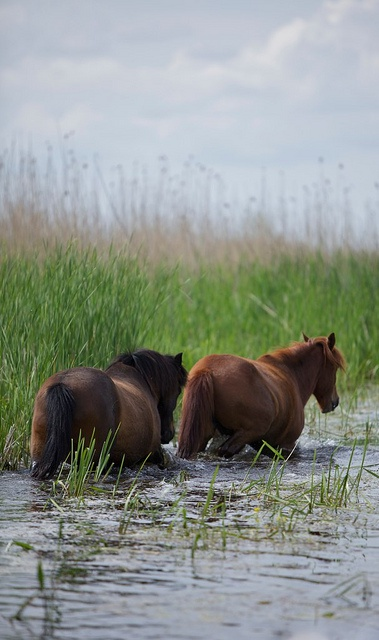Describe the objects in this image and their specific colors. I can see horse in darkgray, black, maroon, olive, and gray tones and horse in darkgray, black, and gray tones in this image. 